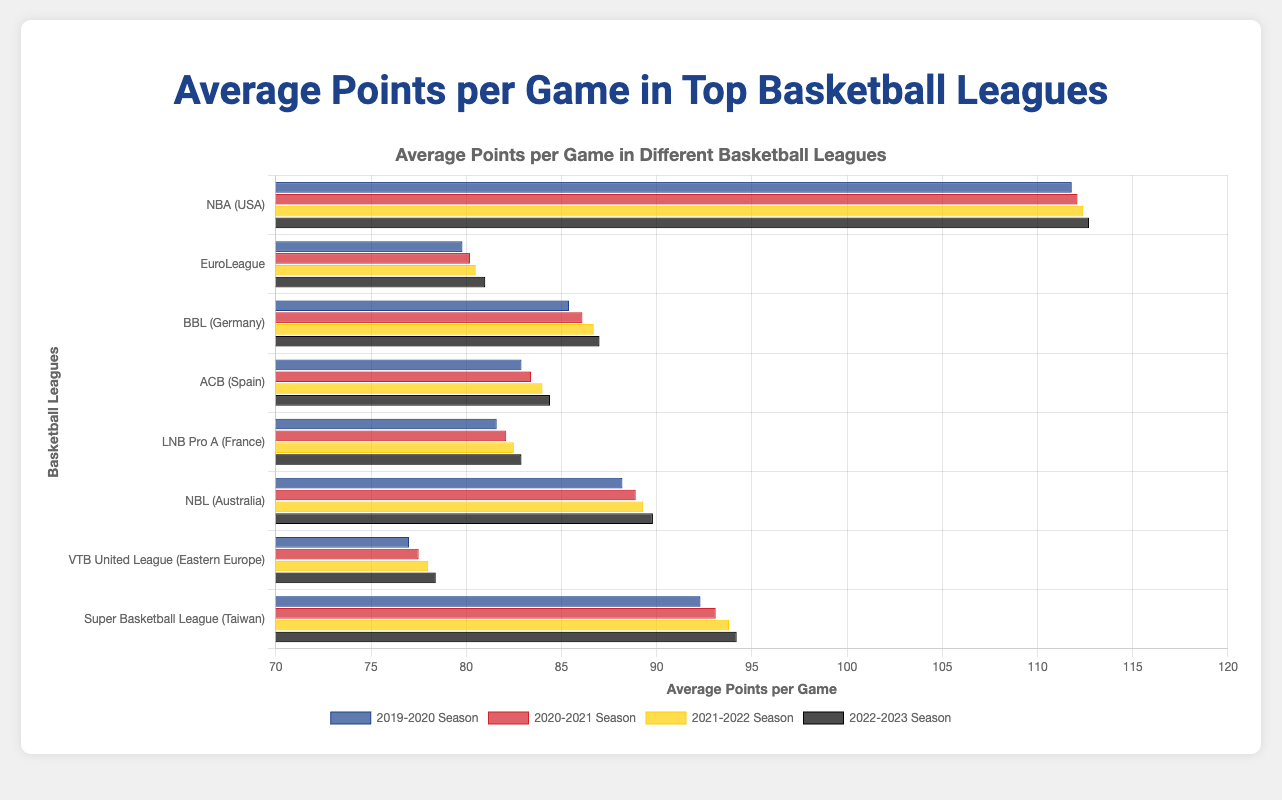Which basketball league had the highest average points per game in the 2019-2020 season? In the 2019-2020 season, the chart shows that the NBA (USA) had the highest average points per game, as it's the tallest bar.
Answer: NBA (USA) Has the average points per game for the EuroLeague increased or decreased from the 2019-2020 season to the 2022-2023 season? To determine the trend, check the height of the EuroLeague's bars for the 2019-2020 and 2022-2023 seasons. The bars indicate an increase from 79.8 to 81.0.
Answer: Increased Which league saw the largest increase in average points per game from the 2019-2020 season to the 2022-2023 season? Calculate the difference for each league. For BBL (Germany): 87.0 - 85.4 = 1.6. For NBA: 112.7 - 111.8 = 0.9. Repeat for all leagues. The Super Basketball League (Taiwan) shows the largest increase of 94.2 - 92.3 = 1.9 points.
Answer: Super Basketball League (Taiwan) What's the difference in average points per game between the NBA (USA) and BBL (Germany) in the 2022-2023 season? Subtract the average points of BBL (Germany) (87.0) from that of the NBA (USA) (112.7).
Answer: 25.7 Which season shows the highest average points per game for the NBL (Australia)? Compare the heights of the NBL (Australia) bars across all seasons. The 2022-2023 season has the highest bar at 89.8 points.
Answer: 2022-2023 season What is the combined average points per game for the LNB Pro A (France) and ACB (Spain) in the 2022-2023 season? Add the average points per game for LNB Pro A (France) (82.9) and ACB (Spain) (84.4).
Answer: 167.3 Which leagues have had consistent increases in average points per game across all seasons shown? Identify leagues where the height of the bars increases sequentially for all seasons. NBA (USA) and Super Basketball League (Taiwan) both show consistent increases.
Answer: NBA (USA) and Super Basketball League (Taiwan) What is the average increase in points per game per season for BBL (Germany) from 2019-2020 to 2022-2023? Calculate the increase for each season and then average them: (86.1-85.4) + (86.7-86.1) + (87.0-86.7) = 0.7 + 0.6 + 0.3 = 1.6; then 1.6 / 3 seasons = 0.53.
Answer: 0.53 In which season did the VTB United League (Eastern Europe) see its lowest average points per game? Compare the VTB United League (Eastern Europe) bars for each season to identify the shortest bar. The 2019-2020 season has the lowest at 77.0 points.
Answer: 2019-2020 season Which league had higher average points per game in the 2020-2021 season, ACB (Spain) or BBL (Germany)? Compare the height of the bars for ACB (Spain) (83.4) and BBL (Germany) (86.1) in the 2020-2021 season.
Answer: BBL (Germany) 